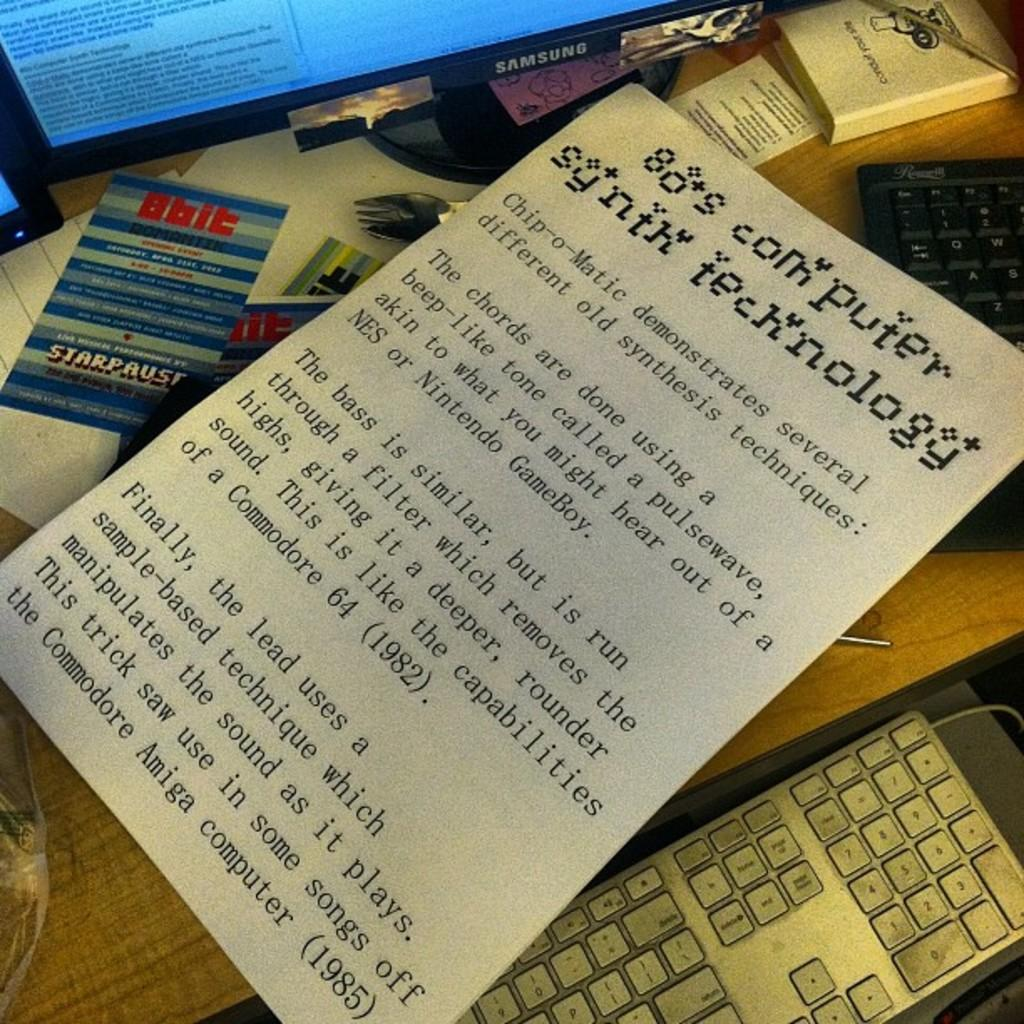<image>
Relay a brief, clear account of the picture shown. A piece of paper explaining 80s computer synth technology sits on a desk. 